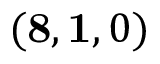<formula> <loc_0><loc_0><loc_500><loc_500>( 8 , 1 , 0 )</formula> 